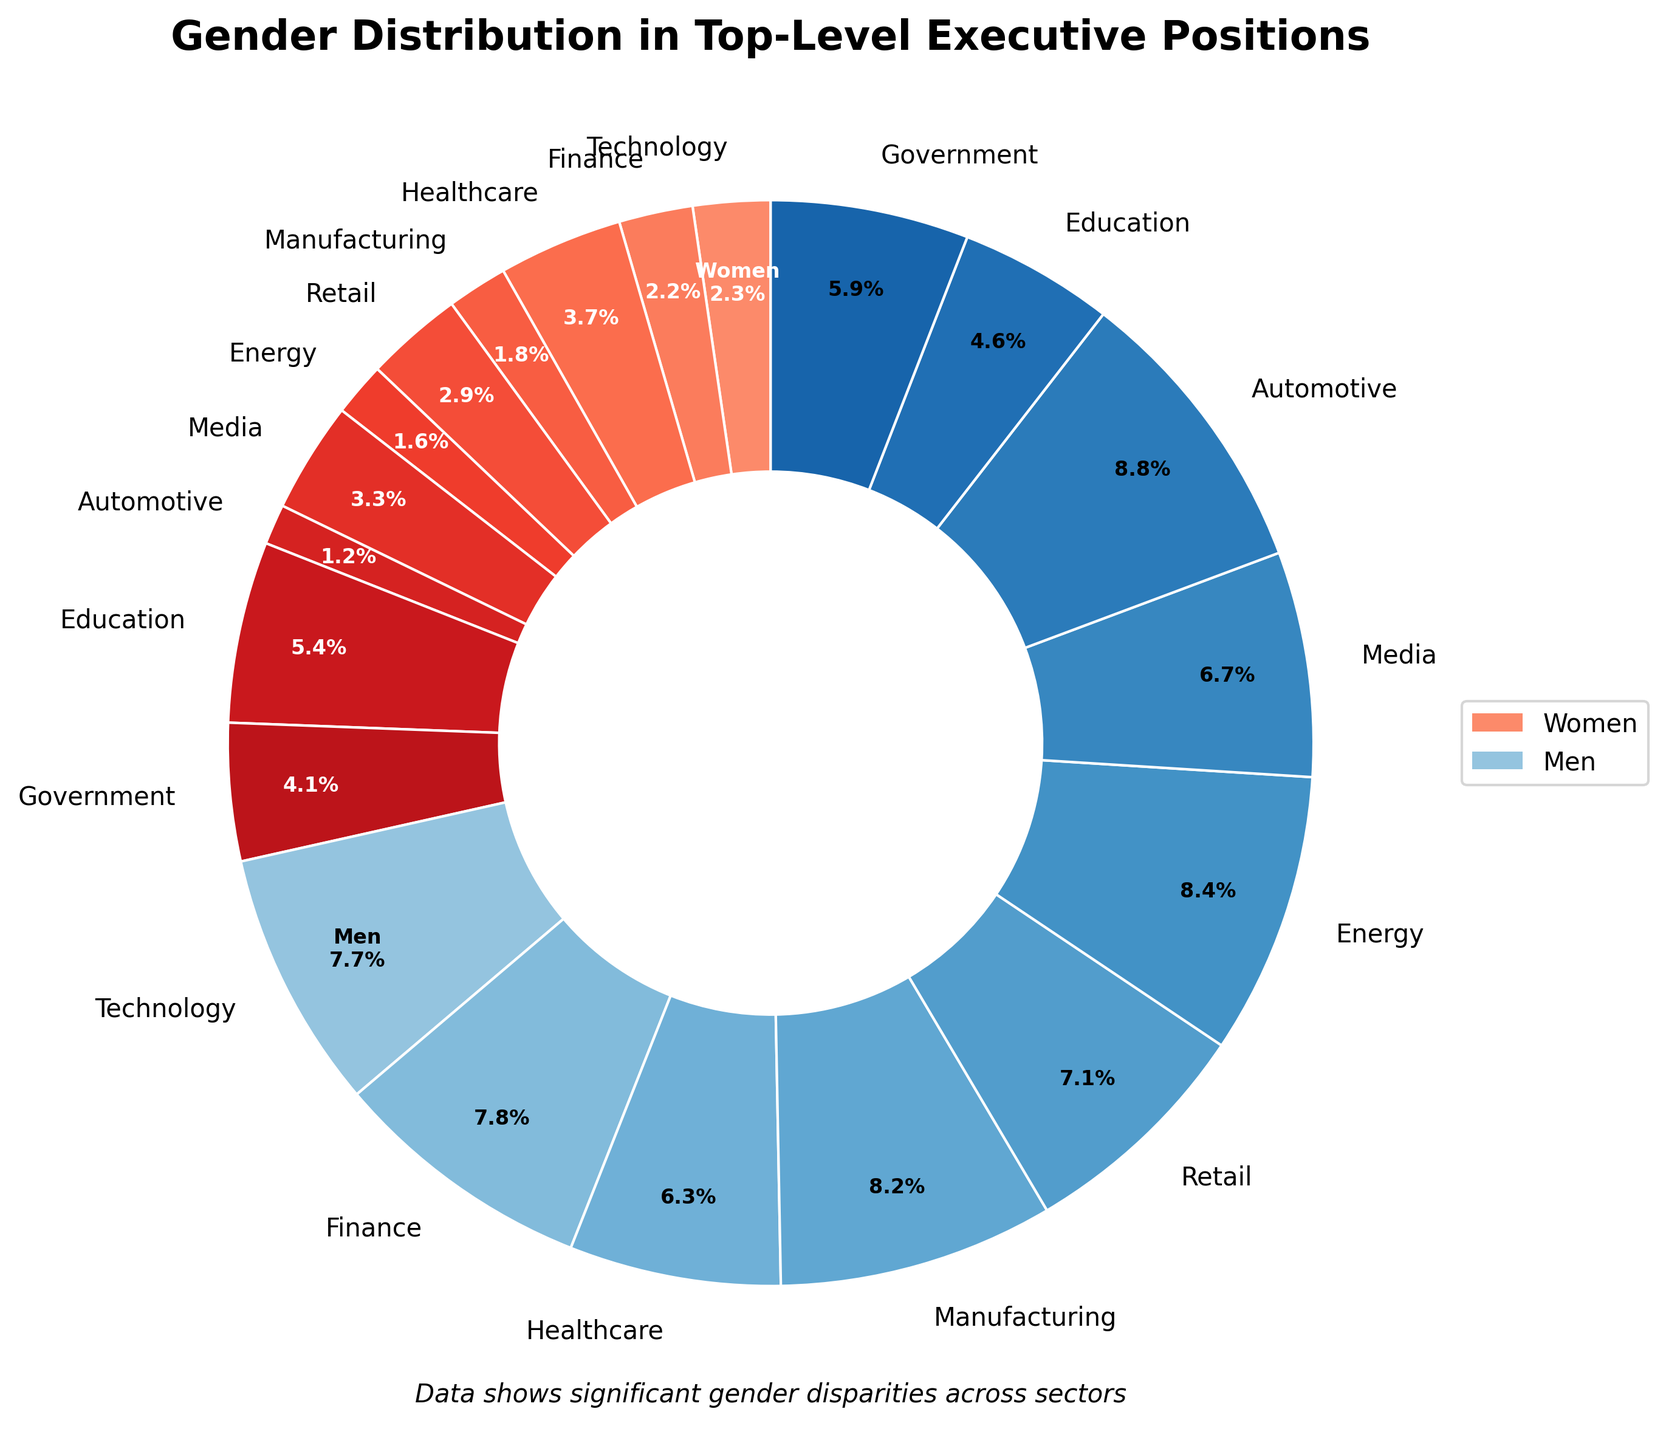What sector has the highest percentage of women in top-level executive positions? The chart shows the percentages of women in various sectors. By comparing these percentages, Education is seen to have the highest at 54%.
Answer: Education Which sector has the lowest percentage of women in top-level executive positions? By comparing the percentages of women across all sectors, Automotive is shown to have the lowest percentage at 12%.
Answer: Automotive What is the difference in percentage of women in top-level executive positions between the Healthcare and Manufacturing sectors? The percentage of women in Healthcare is 37%, and in Manufacturing, it is 18%. The difference is 37% - 18% = 19%.
Answer: 19% What is the total percentage of women in top-level executive positions across Technology, Media, and Government sectors combined? Adding the percentages of women in Technology (23%), Media (33%), and Government (41%) results in a total of 23% + 33% + 41% = 97%.
Answer: 97% Which sector shows a higher gender disparity: Technology or Energy? Gender disparity can be calculated by the difference between 100% and the percentage of women. For Technology, it is 100% - 23% = 77%. For Energy, it is 100% - 16% = 84%. Energy has a higher disparity because 84% is greater than 77%.
Answer: Energy What is the average percentage of women in top-level executive positions across all sectors? Summing the percentages of women in all sectors and dividing by the number of sectors (10): (23% + 22% + 37% + 18% + 29% + 16% + 33% + 12% + 54% + 41%) / 10 = 28.5%.
Answer: 28.5% Compare the percentages of women in the Finance and Retail sectors. Which one has a higher percentage and by how much? Finance has 22% women, and Retail has 29% women. Retail has a higher percentage. The difference is 29% - 22% = 7%.
Answer: Retail, 7% What is the combined percentage of men in top-level executive positions in the Automotive and Manufacturing sectors? The percentage of men in Automotive is 100% - 12% = 88%, and in Manufacturing, it is 100% - 18% = 82%. The combined percentage is 88% + 82% = 170%.
Answer: 170% How does the visual contrast between the colors representing men and women help in understanding the gender distribution? The colors for women range from lighter to darker reds and for men from lighter to darker blues. This visual contrast makes it easier to differentiate and directly compare gender distribution within and across sectors.
Answer: Clear differentiation 